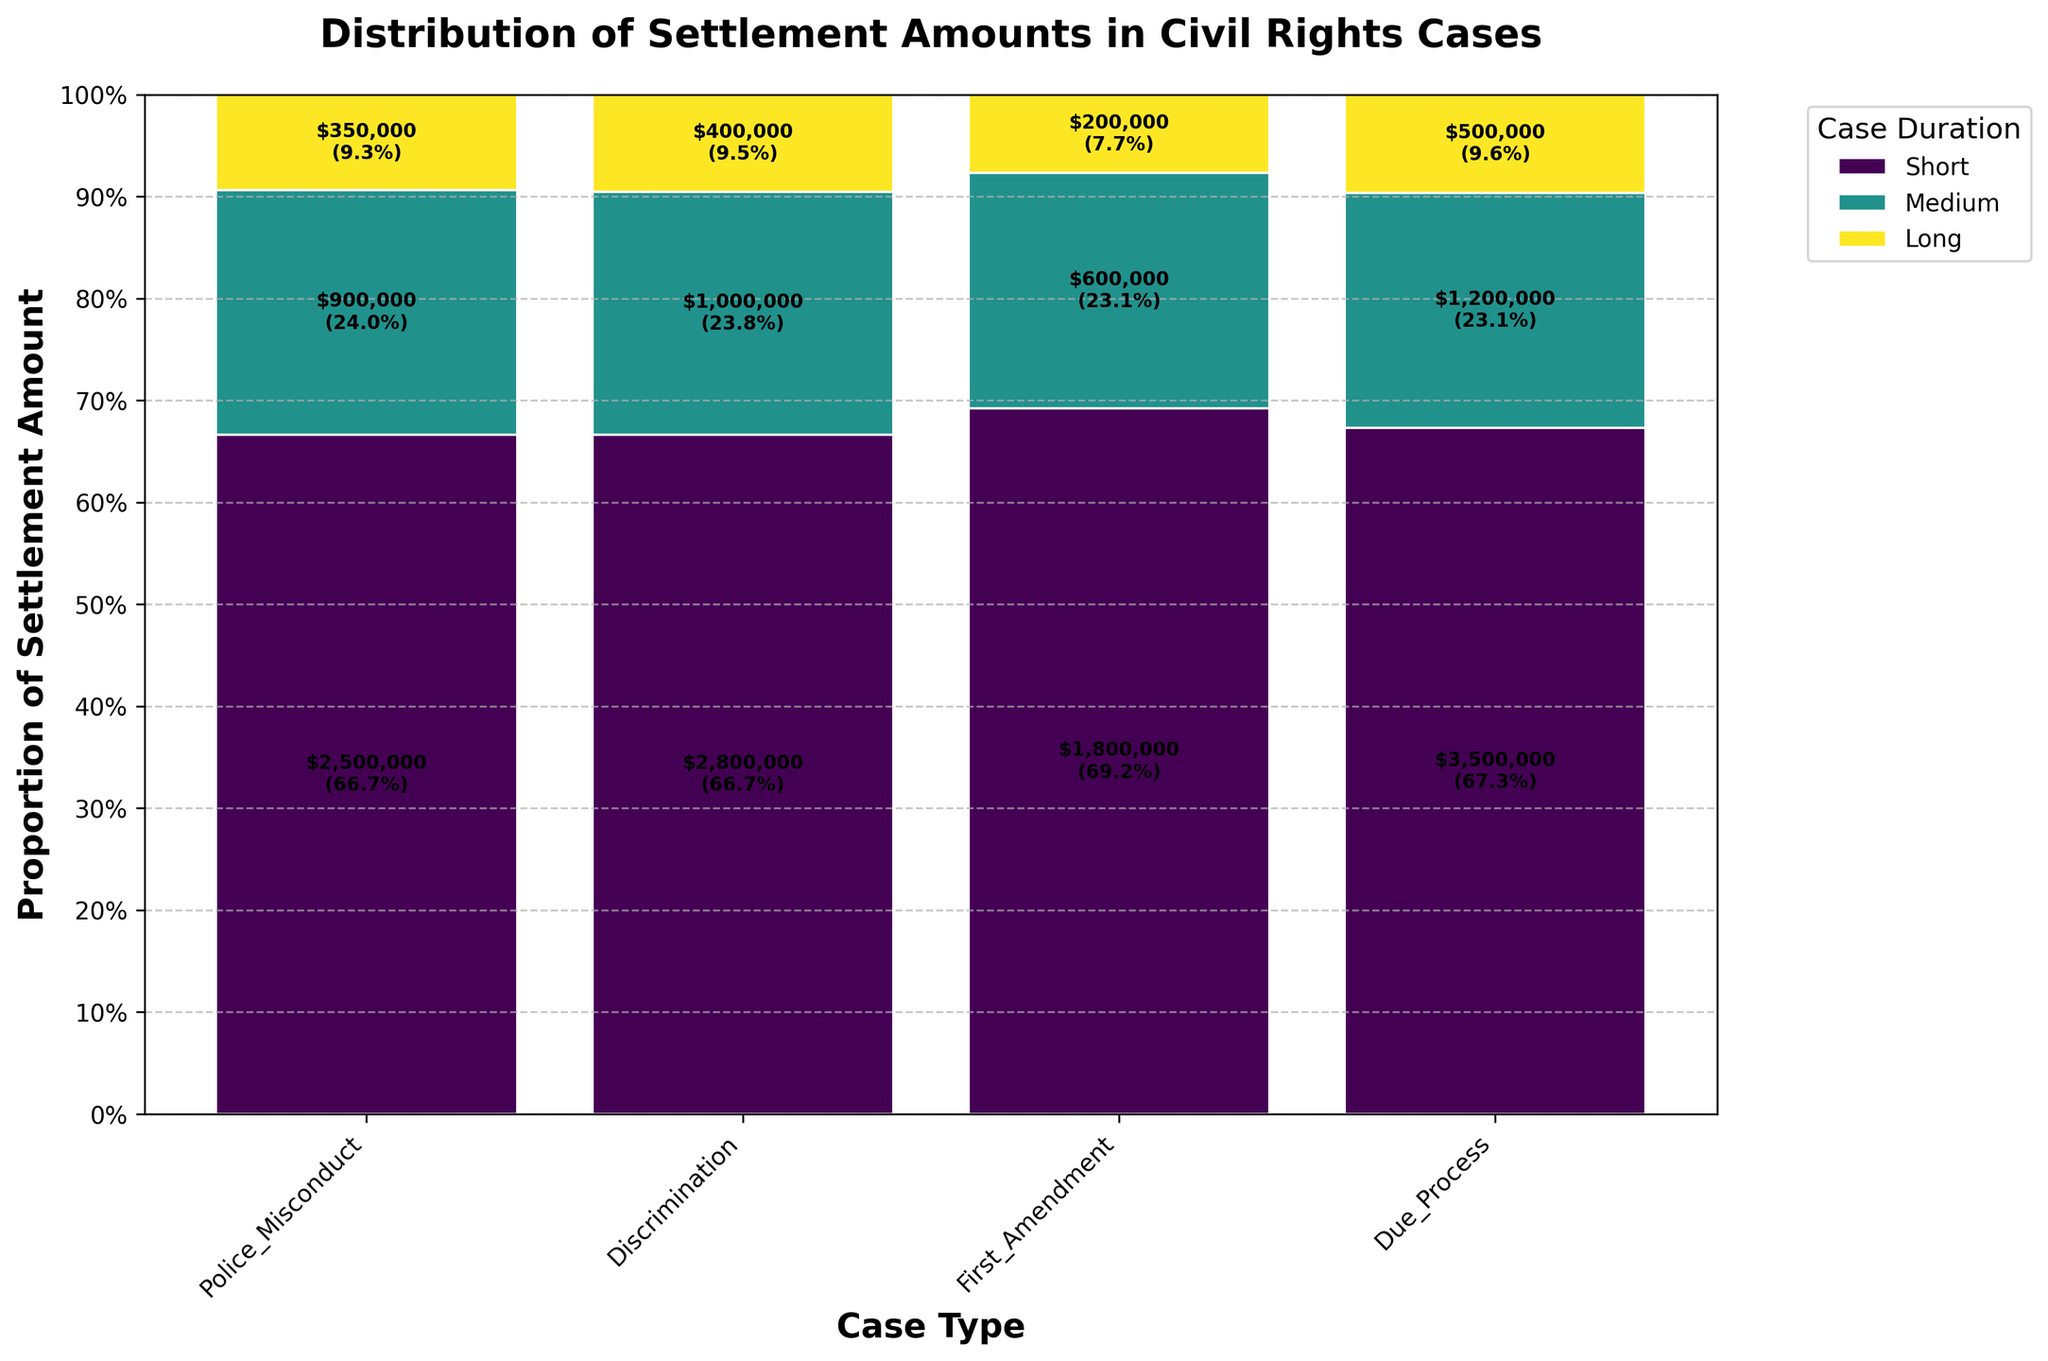What's the title of the plot? The title is displayed at the top of the plot in a larger and bold font, identifying what the plot represents.
Answer: Distribution of Settlement Amounts in Civil Rights Cases What are the case types represented in the plot? The x-axis of the plot shows different categories that fall under 'Case Type,' labeled for each bar segment.
Answer: Police Misconduct, Discrimination, First Amendment, Due Process Which case type has the highest proportion of settlement amount for long-duration cases? Each bar in the plot is segmented by duration, and the plot uses a specific color to represent each duration type. The height of segments represents the proportion.
Answer: Police Misconduct How many distinct case durations are represented in the plot? The legend on the right side of the plot shows different durations with their corresponding color codes.
Answer: Three (Short, Medium, Long) What's the proportion of settlement amount for medium-duration cases in discrimination cases? Look at the 'Discrimination' category and find the segment colored for medium duration, then note its height as a proportion of the total bar height.
Answer: 18% Which case type has the smallest total settlement amount for short-duration cases, and what is this amount? Examine the bar segments for short-duration cases across all case types, and identify the segment with the smallest value based on the text labels within each segment.
Answer: First Amendment, $200,000 Compare the total legal fees between 'Due Process' and 'Discrimination' cases for long durations. Which one is higher? Identify the total legal fees mentioned within the respective long-duration segments of 'Due Process' and 'Discrimination' cases, comparing the values directly.
Answer: Due Process, $650,000 What is the sum of the settlement amounts for all durations in 'First Amendment' cases? Add up the annotated settlement amounts for all segments within the 'First Amendment' bar.
Answer: $2,600,000 Which duration type contributes the largest proportion of settlement amount in 'Police Misconduct' cases, and what's the amount? In the 'Police Misconduct' category, identify the segment with the largest proportional height and annotate the amount mentioned in that segment.
Answer: Long duration, $3,500,000 Is there any case type where short-duration cases have the highest proportion of the settlement amount? Inspect the segments representing short-duration cases. Check if any case type has the short-duration segment occupying the largest proportion of the bar height.
Answer: No 